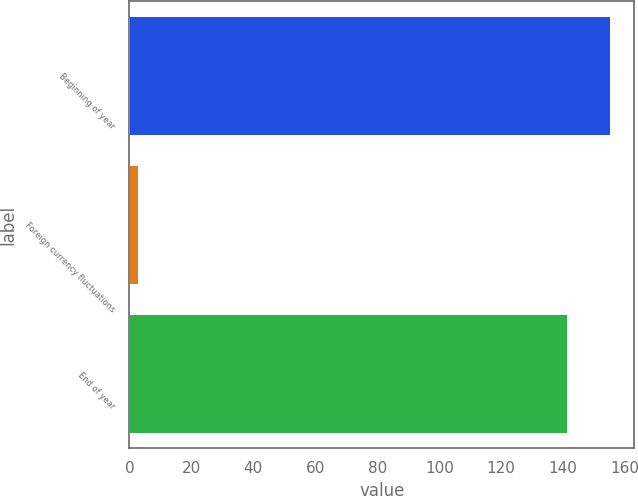Convert chart. <chart><loc_0><loc_0><loc_500><loc_500><bar_chart><fcel>Beginning of year<fcel>Foreign currency fluctuations<fcel>End of year<nl><fcel>155.21<fcel>2.7<fcel>141.1<nl></chart> 